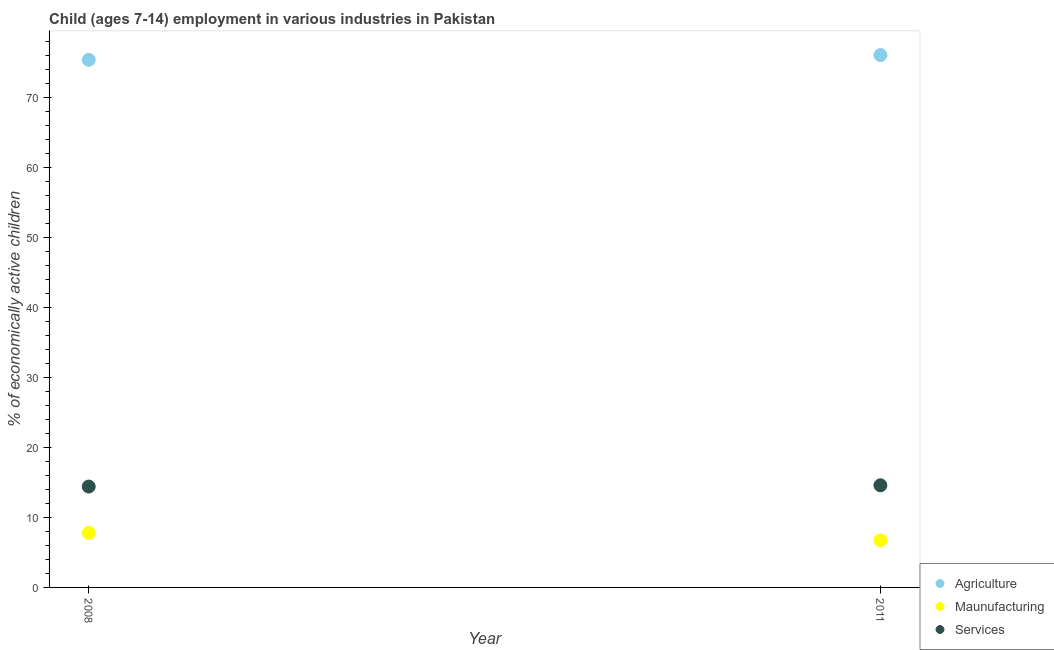What is the percentage of economically active children in services in 2011?
Provide a succinct answer. 14.59. Across all years, what is the maximum percentage of economically active children in manufacturing?
Offer a terse response. 7.79. Across all years, what is the minimum percentage of economically active children in agriculture?
Your answer should be very brief. 75.37. In which year was the percentage of economically active children in agriculture maximum?
Offer a very short reply. 2011. In which year was the percentage of economically active children in services minimum?
Your answer should be very brief. 2008. What is the total percentage of economically active children in manufacturing in the graph?
Your answer should be compact. 14.51. What is the difference between the percentage of economically active children in agriculture in 2008 and that in 2011?
Provide a short and direct response. -0.68. What is the difference between the percentage of economically active children in agriculture in 2011 and the percentage of economically active children in services in 2008?
Keep it short and to the point. 61.64. What is the average percentage of economically active children in agriculture per year?
Provide a short and direct response. 75.71. In the year 2011, what is the difference between the percentage of economically active children in agriculture and percentage of economically active children in manufacturing?
Ensure brevity in your answer.  69.33. In how many years, is the percentage of economically active children in services greater than 30 %?
Your response must be concise. 0. What is the ratio of the percentage of economically active children in services in 2008 to that in 2011?
Keep it short and to the point. 0.99. Is the percentage of economically active children in manufacturing in 2008 less than that in 2011?
Keep it short and to the point. No. In how many years, is the percentage of economically active children in services greater than the average percentage of economically active children in services taken over all years?
Provide a succinct answer. 1. Is the percentage of economically active children in manufacturing strictly less than the percentage of economically active children in agriculture over the years?
Your answer should be compact. Yes. How many dotlines are there?
Keep it short and to the point. 3. How many legend labels are there?
Provide a short and direct response. 3. What is the title of the graph?
Your response must be concise. Child (ages 7-14) employment in various industries in Pakistan. What is the label or title of the X-axis?
Your response must be concise. Year. What is the label or title of the Y-axis?
Ensure brevity in your answer.  % of economically active children. What is the % of economically active children of Agriculture in 2008?
Your answer should be compact. 75.37. What is the % of economically active children of Maunufacturing in 2008?
Provide a succinct answer. 7.79. What is the % of economically active children in Services in 2008?
Provide a short and direct response. 14.41. What is the % of economically active children of Agriculture in 2011?
Give a very brief answer. 76.05. What is the % of economically active children in Maunufacturing in 2011?
Your answer should be very brief. 6.72. What is the % of economically active children in Services in 2011?
Give a very brief answer. 14.59. Across all years, what is the maximum % of economically active children of Agriculture?
Make the answer very short. 76.05. Across all years, what is the maximum % of economically active children in Maunufacturing?
Provide a short and direct response. 7.79. Across all years, what is the maximum % of economically active children of Services?
Provide a short and direct response. 14.59. Across all years, what is the minimum % of economically active children of Agriculture?
Make the answer very short. 75.37. Across all years, what is the minimum % of economically active children of Maunufacturing?
Provide a short and direct response. 6.72. Across all years, what is the minimum % of economically active children in Services?
Your answer should be very brief. 14.41. What is the total % of economically active children in Agriculture in the graph?
Provide a short and direct response. 151.42. What is the total % of economically active children in Maunufacturing in the graph?
Your answer should be compact. 14.51. What is the total % of economically active children of Services in the graph?
Provide a succinct answer. 29. What is the difference between the % of economically active children of Agriculture in 2008 and that in 2011?
Keep it short and to the point. -0.68. What is the difference between the % of economically active children in Maunufacturing in 2008 and that in 2011?
Give a very brief answer. 1.07. What is the difference between the % of economically active children in Services in 2008 and that in 2011?
Your answer should be compact. -0.18. What is the difference between the % of economically active children of Agriculture in 2008 and the % of economically active children of Maunufacturing in 2011?
Provide a succinct answer. 68.65. What is the difference between the % of economically active children in Agriculture in 2008 and the % of economically active children in Services in 2011?
Make the answer very short. 60.78. What is the difference between the % of economically active children in Maunufacturing in 2008 and the % of economically active children in Services in 2011?
Offer a very short reply. -6.8. What is the average % of economically active children in Agriculture per year?
Provide a short and direct response. 75.71. What is the average % of economically active children of Maunufacturing per year?
Provide a short and direct response. 7.25. In the year 2008, what is the difference between the % of economically active children in Agriculture and % of economically active children in Maunufacturing?
Provide a short and direct response. 67.58. In the year 2008, what is the difference between the % of economically active children in Agriculture and % of economically active children in Services?
Offer a very short reply. 60.96. In the year 2008, what is the difference between the % of economically active children of Maunufacturing and % of economically active children of Services?
Your response must be concise. -6.62. In the year 2011, what is the difference between the % of economically active children of Agriculture and % of economically active children of Maunufacturing?
Your response must be concise. 69.33. In the year 2011, what is the difference between the % of economically active children in Agriculture and % of economically active children in Services?
Give a very brief answer. 61.46. In the year 2011, what is the difference between the % of economically active children in Maunufacturing and % of economically active children in Services?
Your answer should be very brief. -7.87. What is the ratio of the % of economically active children in Maunufacturing in 2008 to that in 2011?
Offer a terse response. 1.16. What is the difference between the highest and the second highest % of economically active children of Agriculture?
Ensure brevity in your answer.  0.68. What is the difference between the highest and the second highest % of economically active children of Maunufacturing?
Ensure brevity in your answer.  1.07. What is the difference between the highest and the second highest % of economically active children in Services?
Your response must be concise. 0.18. What is the difference between the highest and the lowest % of economically active children of Agriculture?
Ensure brevity in your answer.  0.68. What is the difference between the highest and the lowest % of economically active children of Maunufacturing?
Offer a terse response. 1.07. What is the difference between the highest and the lowest % of economically active children in Services?
Your answer should be very brief. 0.18. 